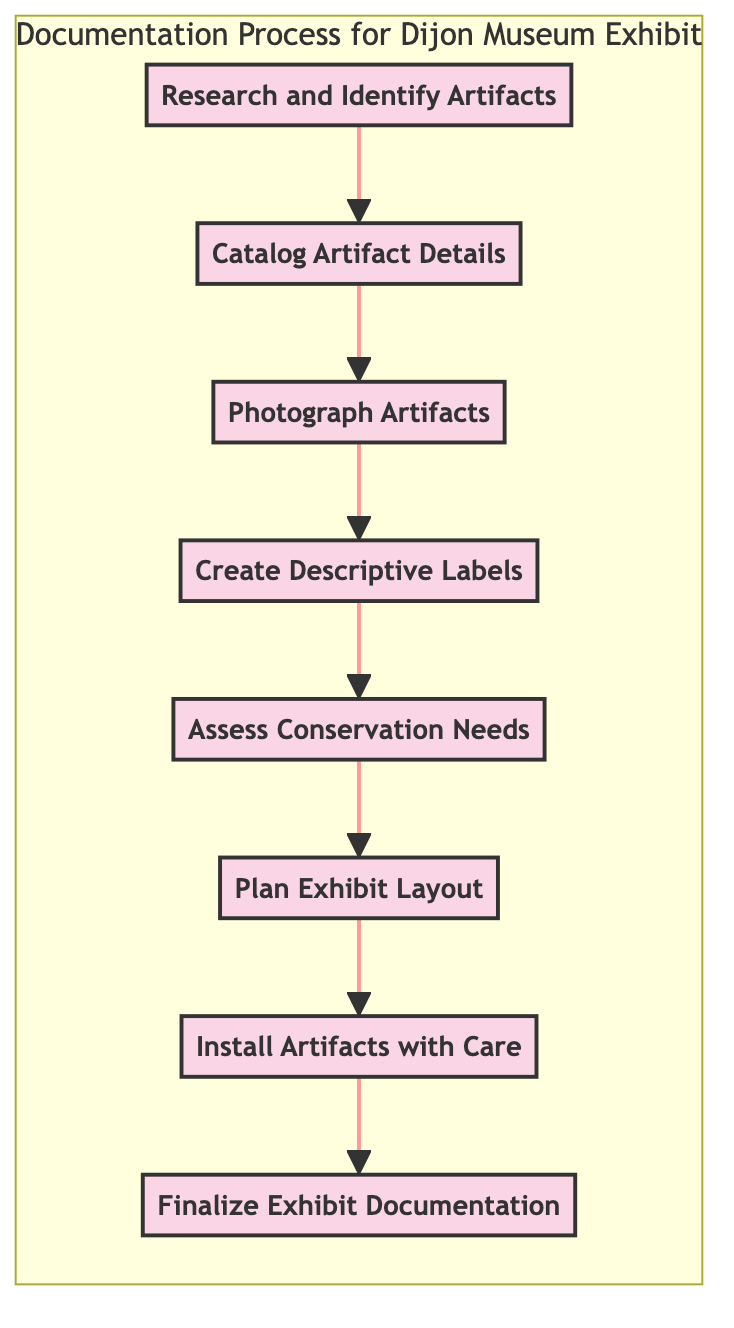What is the first step in the diagram? The first step mentioned in the diagram is "Research and Identify Artifacts." This is indicated as the starting node of the flowchart connected to subsequent steps.
Answer: Research and Identify Artifacts How many total steps are in the diagram? The diagram outlines a total of eight steps, counting from "Research and Identify Artifacts" to "Finalize Exhibit Documentation." This can be verified by counting each node in the flowchart.
Answer: 8 What follows after "Create Descriptive Labels"? The step that follows "Create Descriptive Labels" is "Assess Conservation Needs." This can be seen in the directional flow from one step to the next in the diagram.
Answer: Assess Conservation Needs What is the final step of the process? The final step in the diagram is "Finalize Exhibit Documentation." This represents the conclusion of the flowchart process and is placed at the end of the flow.
Answer: Finalize Exhibit Documentation Which step involves taking photographs of artifacts? The step that involves taking photographs of artifacts is "Photograph Artifacts." This is specifically mentioned as step 3 in the diagram and is directly connected from step 2.
Answer: Photograph Artifacts What is the relationship between "Assess Conservation Needs" and "Plan Exhibit Layout"? "Assess Conservation Needs" precedes "Plan Exhibit Layout" in the flowchart, indicating a sequential relationship where evaluating conservation needs must happen before planning the exhibit layout.
Answer: Sequential relationship How does "Install Artifacts with Care" relate to the overall exhibit process? "Install Artifacts with Care" is a critical step that comes after planning the exhibit layout and focuses on the proper placement of artifacts in their designated areas according to the layout. This ensures artifacts are displayed appropriately, safeguarding their condition.
Answer: Critical step for display Which step recommends consulting a professional conservator? The step that recommends consulting a professional conservator is "Assess Conservation Needs." This step evaluates whether artifacts require conservation actions, and if so, suggests seeking professional advice.
Answer: Assess Conservation Needs 